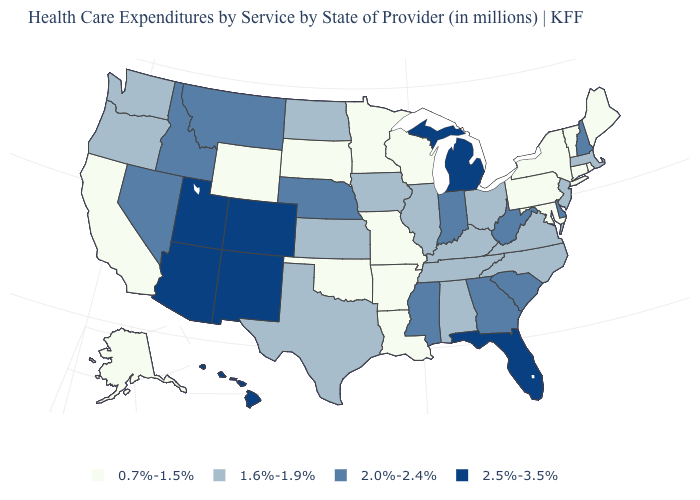Does Maine have the lowest value in the USA?
Concise answer only. Yes. What is the highest value in the USA?
Short answer required. 2.5%-3.5%. What is the value of Massachusetts?
Keep it brief. 1.6%-1.9%. Which states have the lowest value in the USA?
Write a very short answer. Alaska, Arkansas, California, Connecticut, Louisiana, Maine, Maryland, Minnesota, Missouri, New York, Oklahoma, Pennsylvania, Rhode Island, South Dakota, Vermont, Wisconsin, Wyoming. Name the states that have a value in the range 0.7%-1.5%?
Give a very brief answer. Alaska, Arkansas, California, Connecticut, Louisiana, Maine, Maryland, Minnesota, Missouri, New York, Oklahoma, Pennsylvania, Rhode Island, South Dakota, Vermont, Wisconsin, Wyoming. Name the states that have a value in the range 0.7%-1.5%?
Short answer required. Alaska, Arkansas, California, Connecticut, Louisiana, Maine, Maryland, Minnesota, Missouri, New York, Oklahoma, Pennsylvania, Rhode Island, South Dakota, Vermont, Wisconsin, Wyoming. Which states hav the highest value in the Northeast?
Give a very brief answer. New Hampshire. What is the highest value in the West ?
Short answer required. 2.5%-3.5%. What is the lowest value in the USA?
Write a very short answer. 0.7%-1.5%. Which states have the lowest value in the USA?
Quick response, please. Alaska, Arkansas, California, Connecticut, Louisiana, Maine, Maryland, Minnesota, Missouri, New York, Oklahoma, Pennsylvania, Rhode Island, South Dakota, Vermont, Wisconsin, Wyoming. Name the states that have a value in the range 2.0%-2.4%?
Write a very short answer. Delaware, Georgia, Idaho, Indiana, Mississippi, Montana, Nebraska, Nevada, New Hampshire, South Carolina, West Virginia. What is the highest value in states that border North Carolina?
Short answer required. 2.0%-2.4%. Which states have the highest value in the USA?
Write a very short answer. Arizona, Colorado, Florida, Hawaii, Michigan, New Mexico, Utah. Among the states that border Indiana , does Michigan have the highest value?
Give a very brief answer. Yes. Does Vermont have a lower value than Arkansas?
Concise answer only. No. 